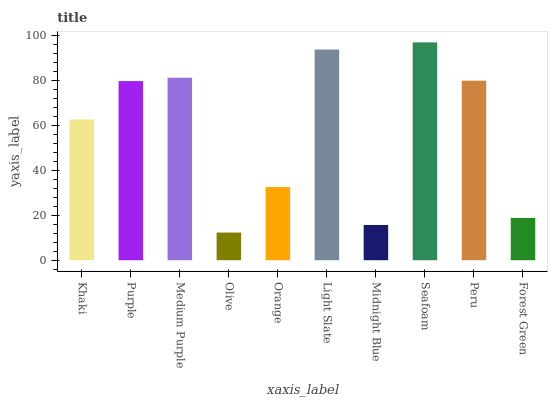Is Olive the minimum?
Answer yes or no. Yes. Is Seafoam the maximum?
Answer yes or no. Yes. Is Purple the minimum?
Answer yes or no. No. Is Purple the maximum?
Answer yes or no. No. Is Purple greater than Khaki?
Answer yes or no. Yes. Is Khaki less than Purple?
Answer yes or no. Yes. Is Khaki greater than Purple?
Answer yes or no. No. Is Purple less than Khaki?
Answer yes or no. No. Is Purple the high median?
Answer yes or no. Yes. Is Khaki the low median?
Answer yes or no. Yes. Is Orange the high median?
Answer yes or no. No. Is Seafoam the low median?
Answer yes or no. No. 